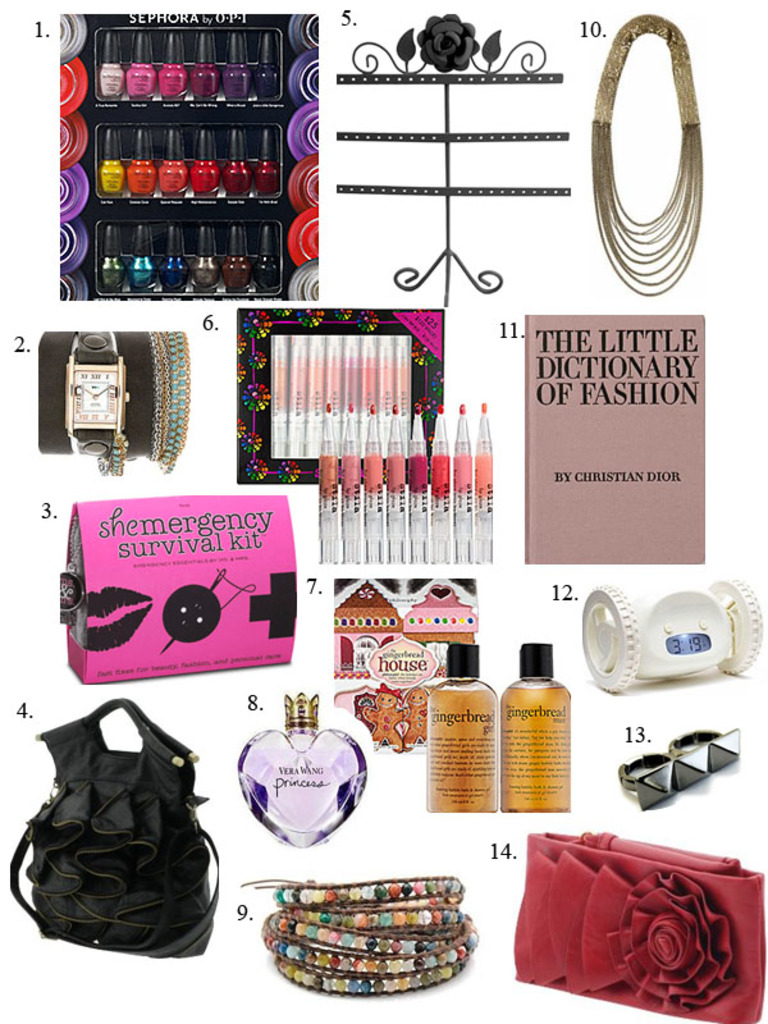Explain the significance of the 'The Little Dictionary of Fashion' by Christian Dior in the field of fashion. 'The Little Dictionary of Fashion' by Christian Dior is a seminal work that offers timeless insights into the principles of dressing elegantly and fashionably, providing advice on how to approach various fashion challenges with grace and style. Can you provide an example of a tip from that book? One prominent tip from Dior's book is about the importance of black in a woman's wardrobe, emphasizing how it can contribute to a look that is both flattering and suitable for many occasions. 